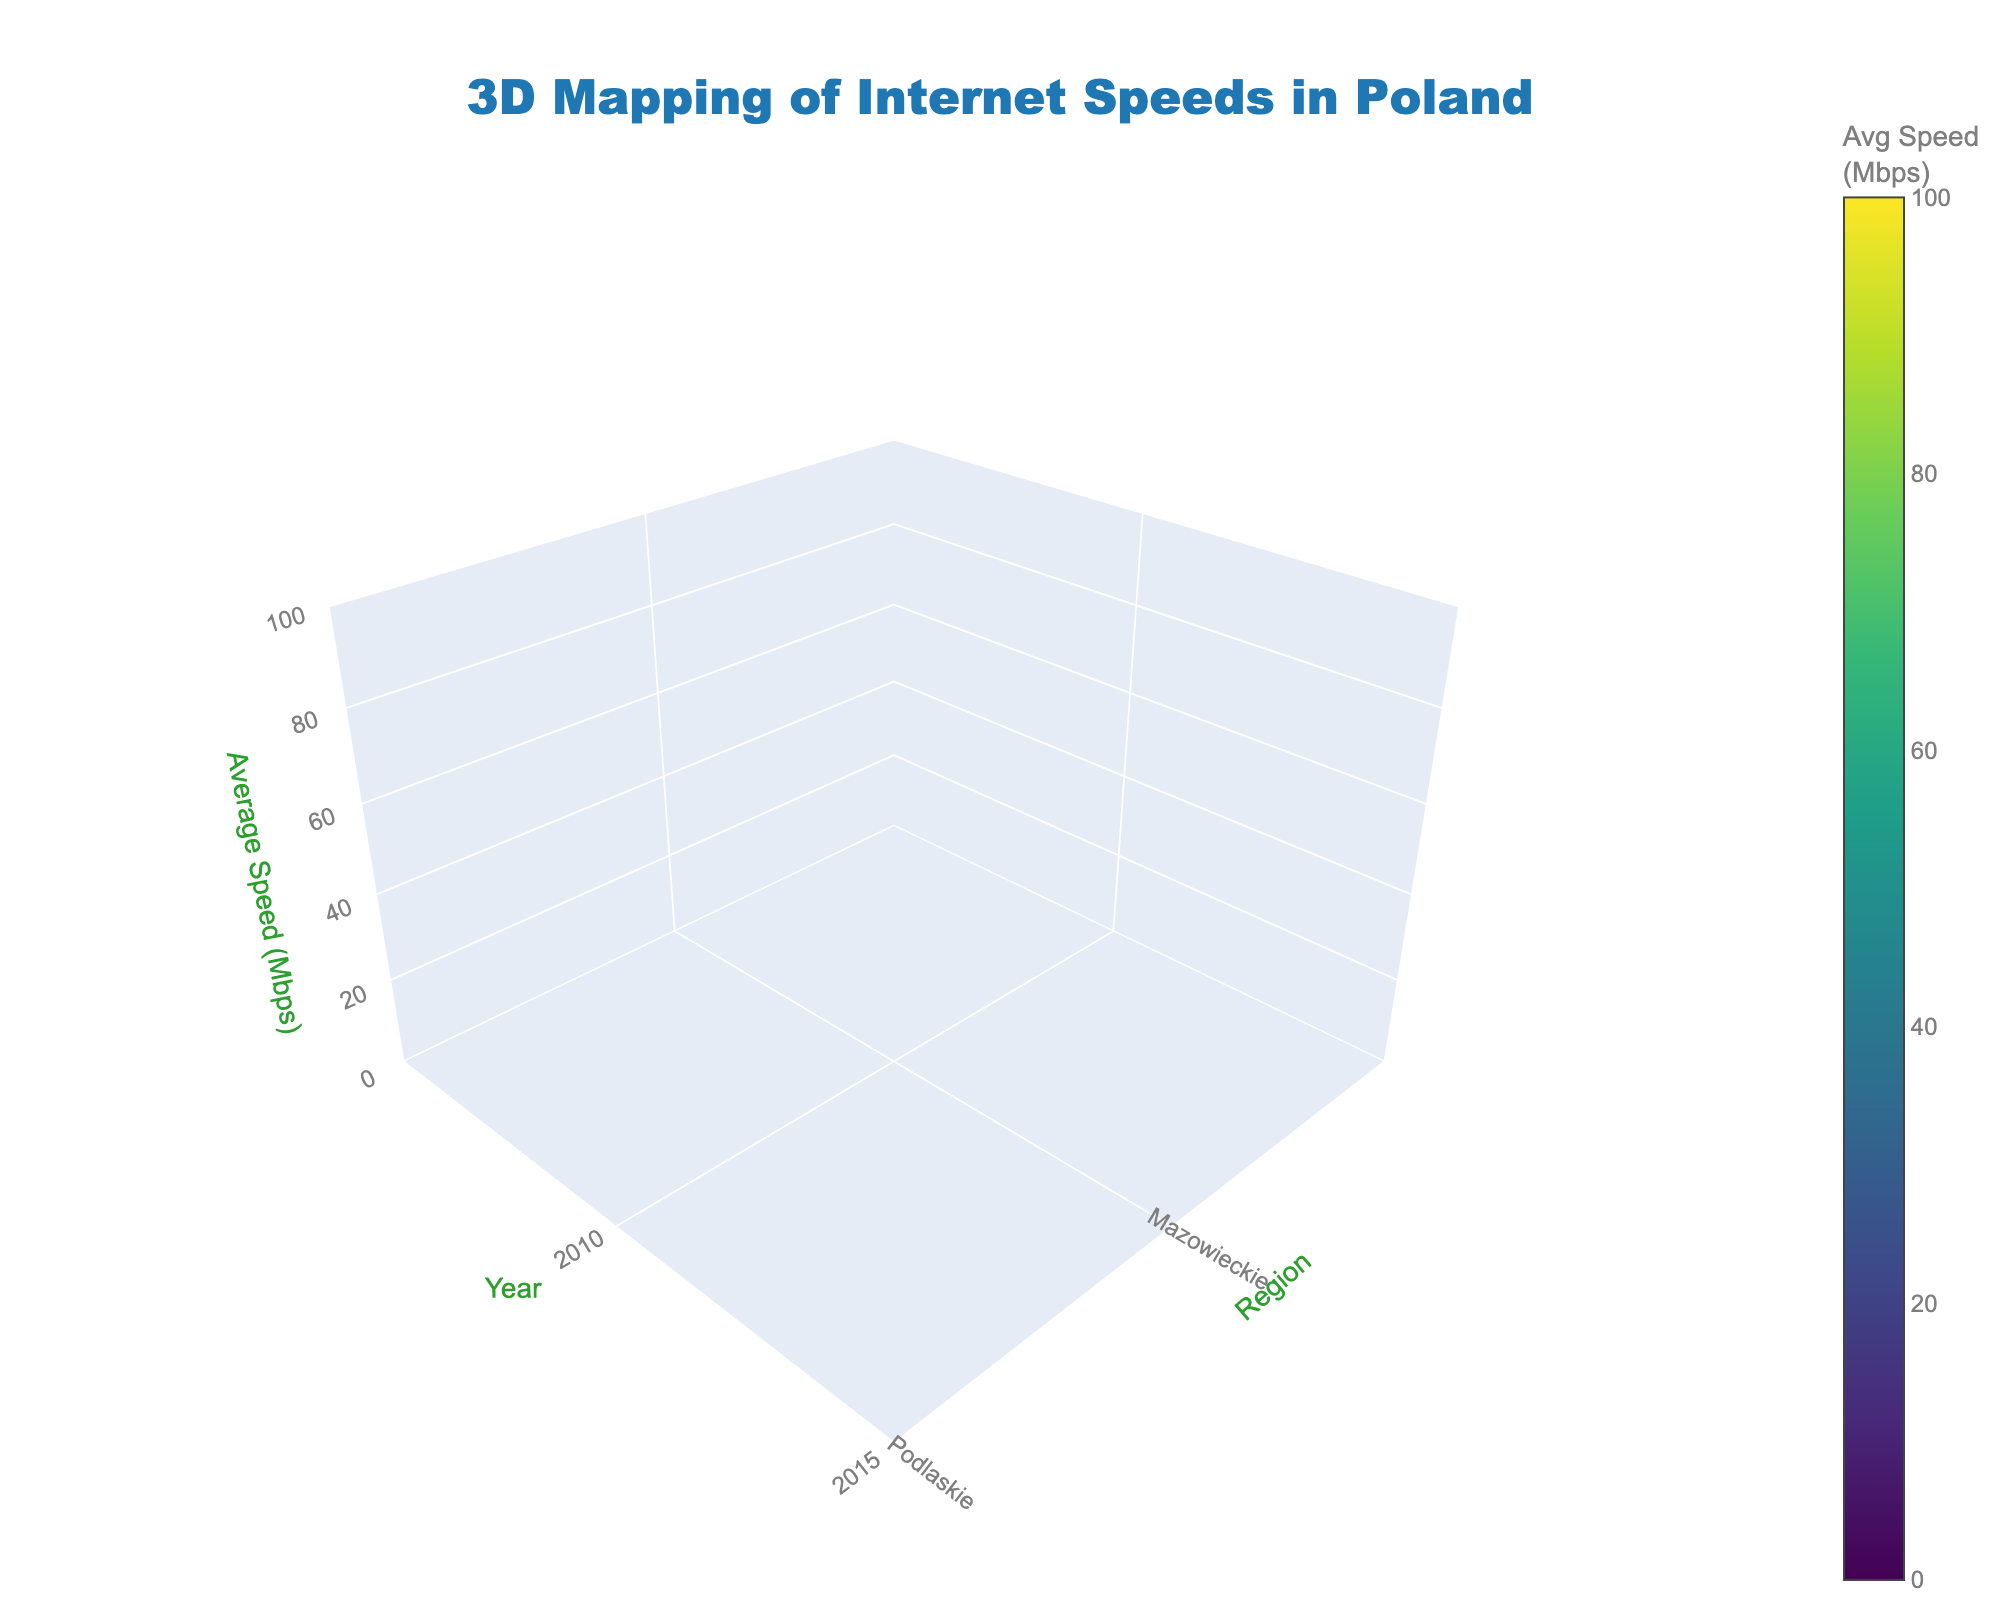What is the title of the 3D volume plot? The title is typically placed at the top of the figure. Reading the uppermost text in the plot provides this information.
Answer: 3D Mapping of Internet Speeds in Poland Which year has the highest average internet speed in rural Podlaskie? Look at the intersecting volume data points for Podlaskie in rural areas over the years. Compare the values for the year 2020 to find the highest speed.
Answer: 2020 How does the average speed in urban Mazowieckie in 2015 compare to that in 2020? Identify the segments for urban Mazowieckie in 2015 and 2020. Compare the heights representing the average speeds for both years. The difference can be visually seen.
Answer: 2020 is higher than 2015 What is the trend in average internet speeds in rural Mazowieckie from 2010 to 2020? Observe the changes in the height of data points representing rural Mazowieckie over 2010, 2015, and 2020. The trend can be deduced by noting if the heights are increasing.
Answer: Increasing How are the internet speeds in urban and rural areas in Mazowieckie in 2015? Look at the heights of the segments representing urban and rural Mazowieckie in 2015. Compare the values visually.
Answer: Urban is significantly higher than rural Comparing Mazowieckie and Podlaskie, which region shows the largest urban-rural disparity in 2020? Examine the height differences between urban and rural segments for Mazowieckie and Podlaskie in 2020. Identify the region with the largest difference.
Answer: Mazowieckie Which region and area type had the lowest average speed in 2010? Check the heights of all the segments in 2010 for each region and area type. The lowest point indicates the answer.
Answer: Rural Podlaskie What is the average internet speed across all regions in 2010? Sum the average speeds for all points in 2010 and divide by the number of data points to find the average.
Answer: (10.5 + 3.2 + 8.1 + 2.5) / 4 = 6.075 What is the increase in average speed for urban areas in Podlaskie from 2010 to 2020? Take the average speeds for urban Podlaskie in 2010 and 2020, then subtract the 2010 value from the 2020 value.
Answer: 82.4 - 8.1 = 74.3 What does the color represent in this figure? Refer to the color scale in the figure to interpret what the color represents, typically provided in a colorbar legend. The color arrangement indicates the specific data range.
Answer: Avg Speed (Mbps) 